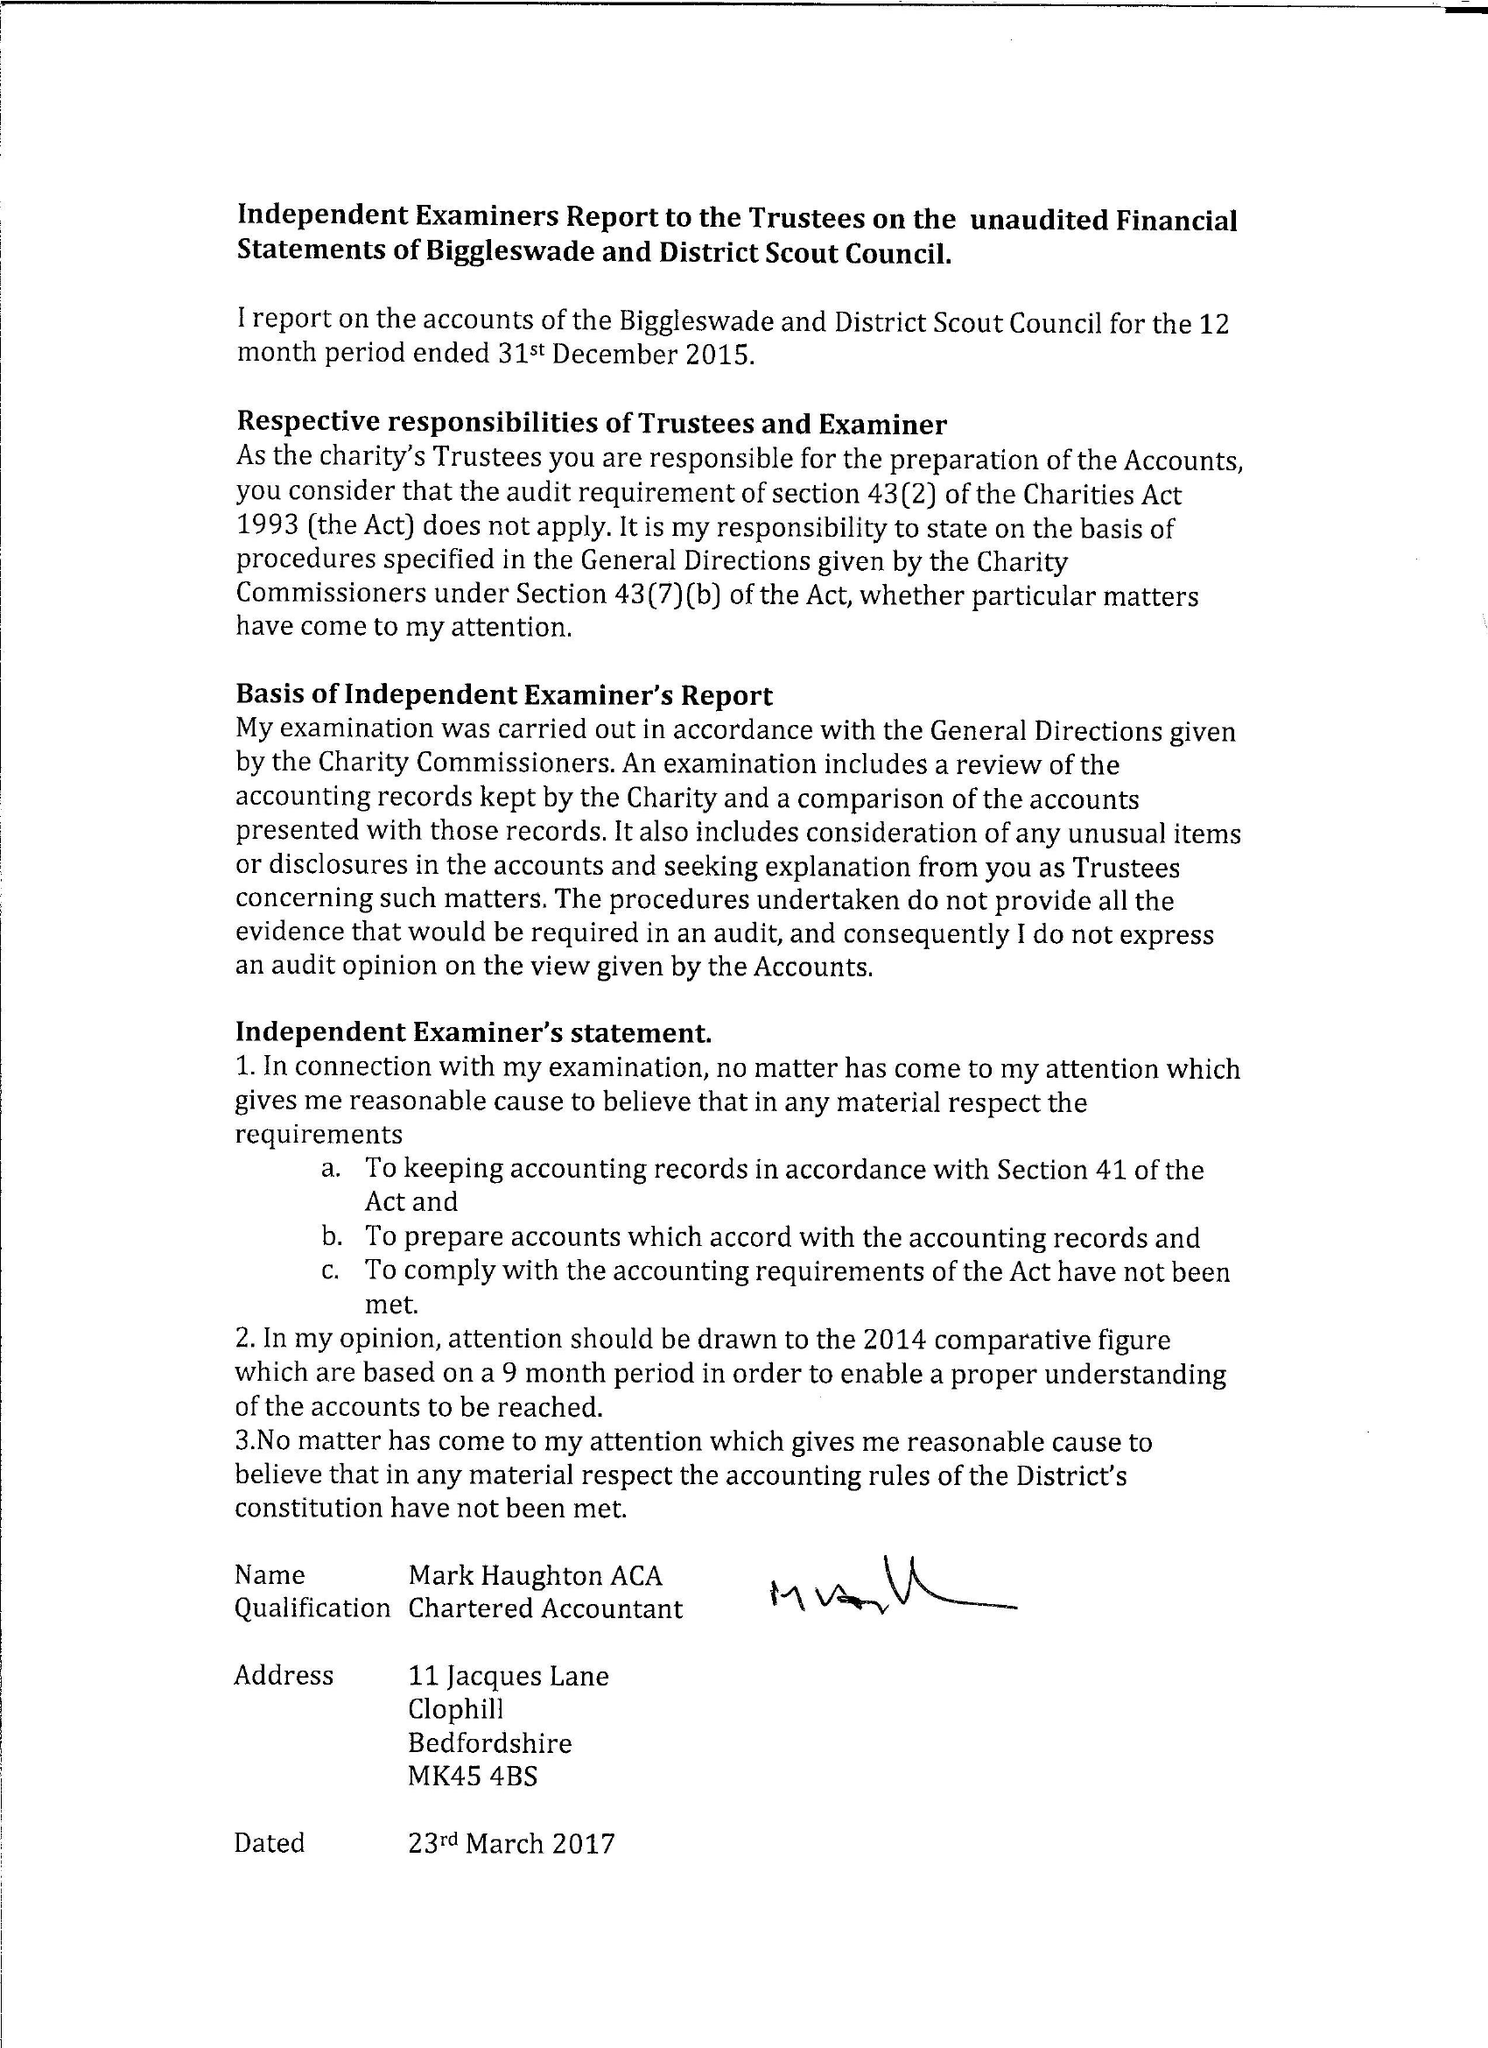What is the value for the spending_annually_in_british_pounds?
Answer the question using a single word or phrase. 35992.00 